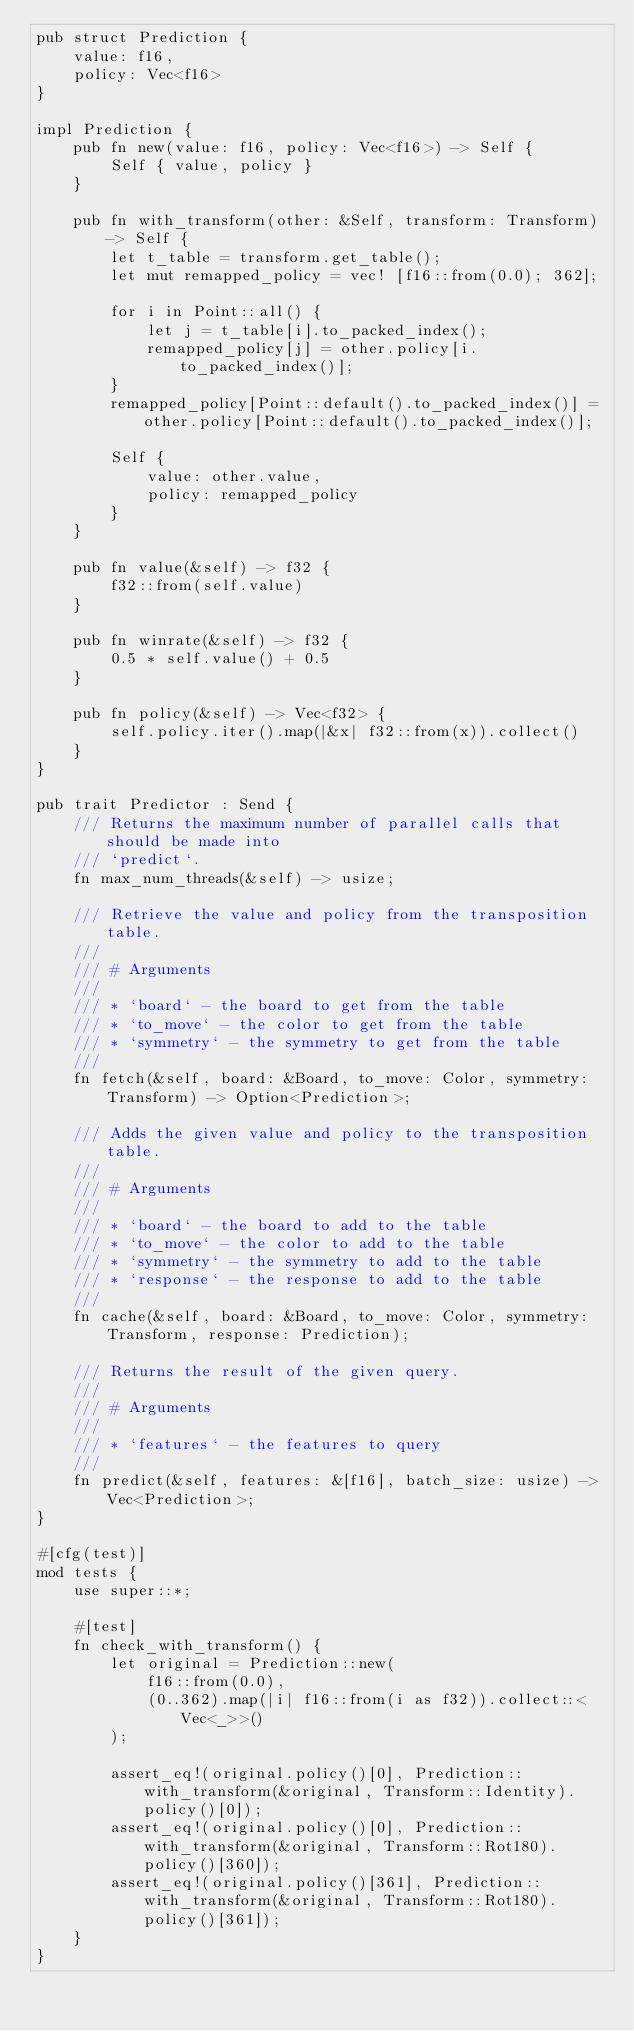Convert code to text. <code><loc_0><loc_0><loc_500><loc_500><_Rust_>pub struct Prediction {
    value: f16,
    policy: Vec<f16>
}

impl Prediction {
    pub fn new(value: f16, policy: Vec<f16>) -> Self {
        Self { value, policy }
    }

    pub fn with_transform(other: &Self, transform: Transform) -> Self {
        let t_table = transform.get_table();
        let mut remapped_policy = vec! [f16::from(0.0); 362];

        for i in Point::all() {
            let j = t_table[i].to_packed_index();
            remapped_policy[j] = other.policy[i.to_packed_index()];
        }
        remapped_policy[Point::default().to_packed_index()] = other.policy[Point::default().to_packed_index()];

        Self {
            value: other.value,
            policy: remapped_policy
        }
    }

    pub fn value(&self) -> f32 {
        f32::from(self.value)
    }

    pub fn winrate(&self) -> f32 {
        0.5 * self.value() + 0.5
    }

    pub fn policy(&self) -> Vec<f32> {
        self.policy.iter().map(|&x| f32::from(x)).collect()
    }
}

pub trait Predictor : Send {
    /// Returns the maximum number of parallel calls that should be made into
    /// `predict`.
    fn max_num_threads(&self) -> usize;

    /// Retrieve the value and policy from the transposition table.
    ///
    /// # Arguments
    ///
    /// * `board` - the board to get from the table
    /// * `to_move` - the color to get from the table
    /// * `symmetry` - the symmetry to get from the table
    ///
    fn fetch(&self, board: &Board, to_move: Color, symmetry: Transform) -> Option<Prediction>;

    /// Adds the given value and policy to the transposition table.
    ///
    /// # Arguments
    ///
    /// * `board` - the board to add to the table
    /// * `to_move` - the color to add to the table
    /// * `symmetry` - the symmetry to add to the table
    /// * `response` - the response to add to the table
    ///
    fn cache(&self, board: &Board, to_move: Color, symmetry: Transform, response: Prediction);

    /// Returns the result of the given query.
    ///
    /// # Arguments
    ///
    /// * `features` - the features to query
    ///
    fn predict(&self, features: &[f16], batch_size: usize) -> Vec<Prediction>;
}

#[cfg(test)]
mod tests {
    use super::*;

    #[test]
    fn check_with_transform() {
        let original = Prediction::new(
            f16::from(0.0),
            (0..362).map(|i| f16::from(i as f32)).collect::<Vec<_>>()
        );

        assert_eq!(original.policy()[0], Prediction::with_transform(&original, Transform::Identity).policy()[0]);
        assert_eq!(original.policy()[0], Prediction::with_transform(&original, Transform::Rot180).policy()[360]);
        assert_eq!(original.policy()[361], Prediction::with_transform(&original, Transform::Rot180).policy()[361]);
    }
}</code> 